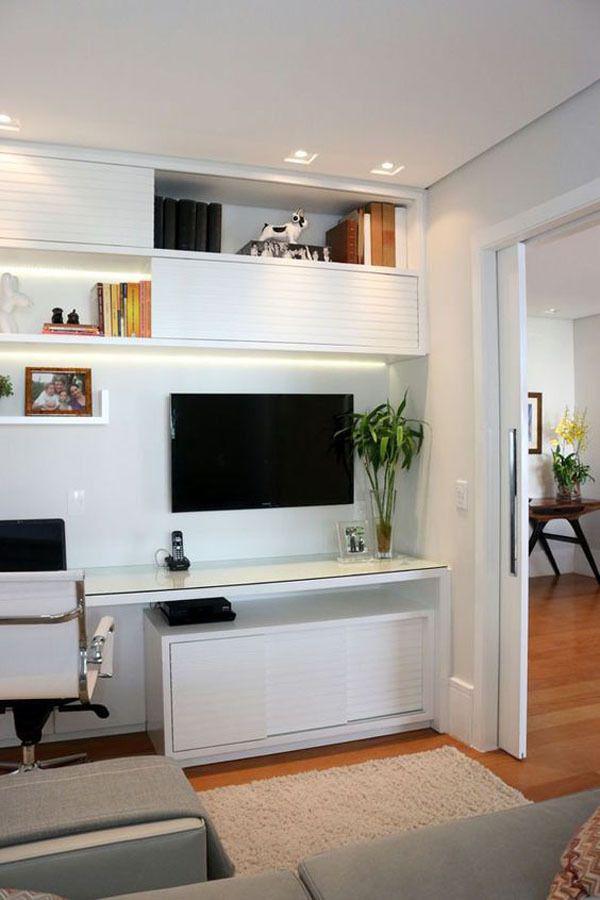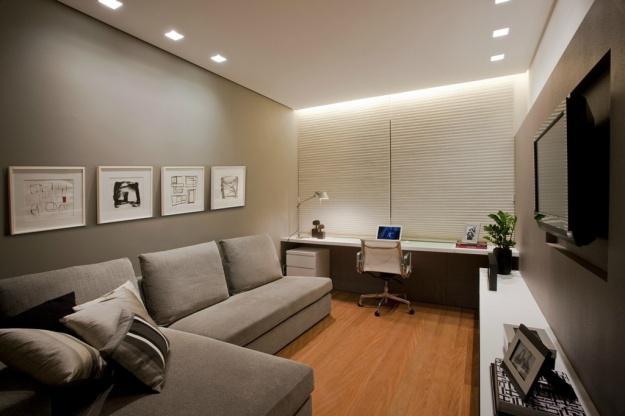The first image is the image on the left, the second image is the image on the right. Analyze the images presented: Is the assertion "There is at least one light dangling from the ceiling." valid? Answer yes or no. No. The first image is the image on the left, the second image is the image on the right. Given the left and right images, does the statement "Curtains cover a window in the image on the left." hold true? Answer yes or no. No. 